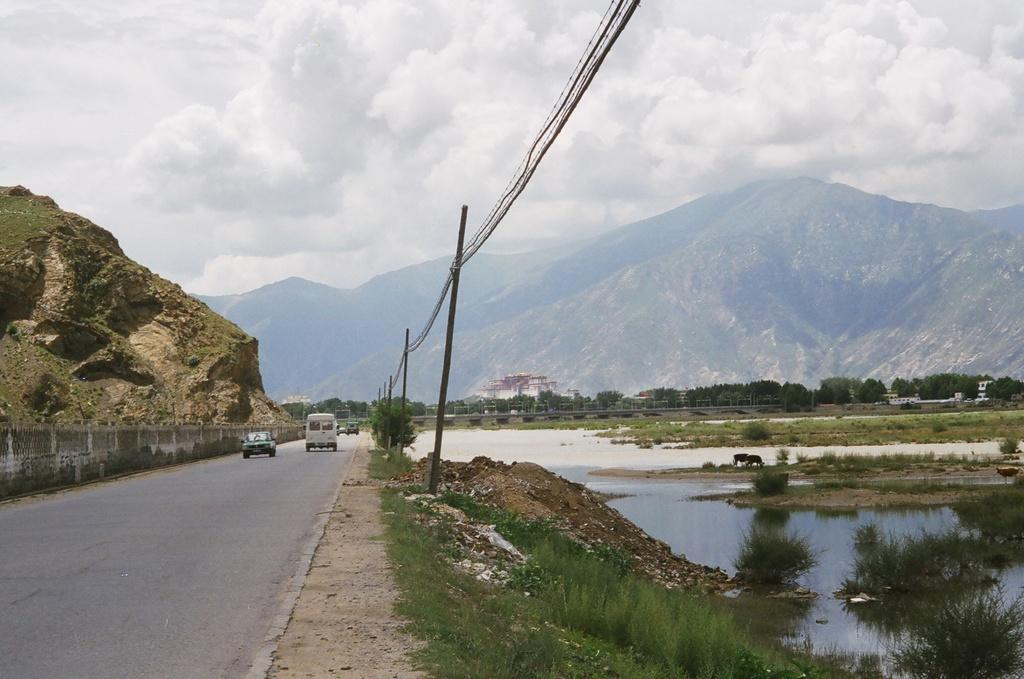What can be seen on the road in the image? There are vehicles on the road in the image. What type of natural environment is visible in the image? There is grass, water, trees, and a mountain visible in the image. What type of structures can be seen in the image? There are poles and buildings visible in the image. What is visible in the background of the image? The sky, clouds, and a mountain are visible in the background of the image. What type of dime is present in the image? There is no dime present in the image. What type of weather can be seen in the image? The provided facts do not mention any specific weather conditions, so we cannot determine the weather from the image. 